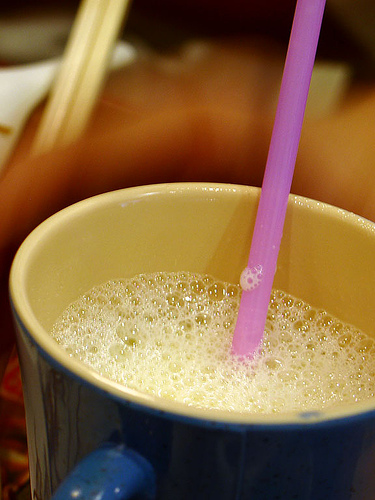<image>
Can you confirm if the coffee is on the spoon? Yes. Looking at the image, I can see the coffee is positioned on top of the spoon, with the spoon providing support. Is the straw above the cup? Yes. The straw is positioned above the cup in the vertical space, higher up in the scene. 